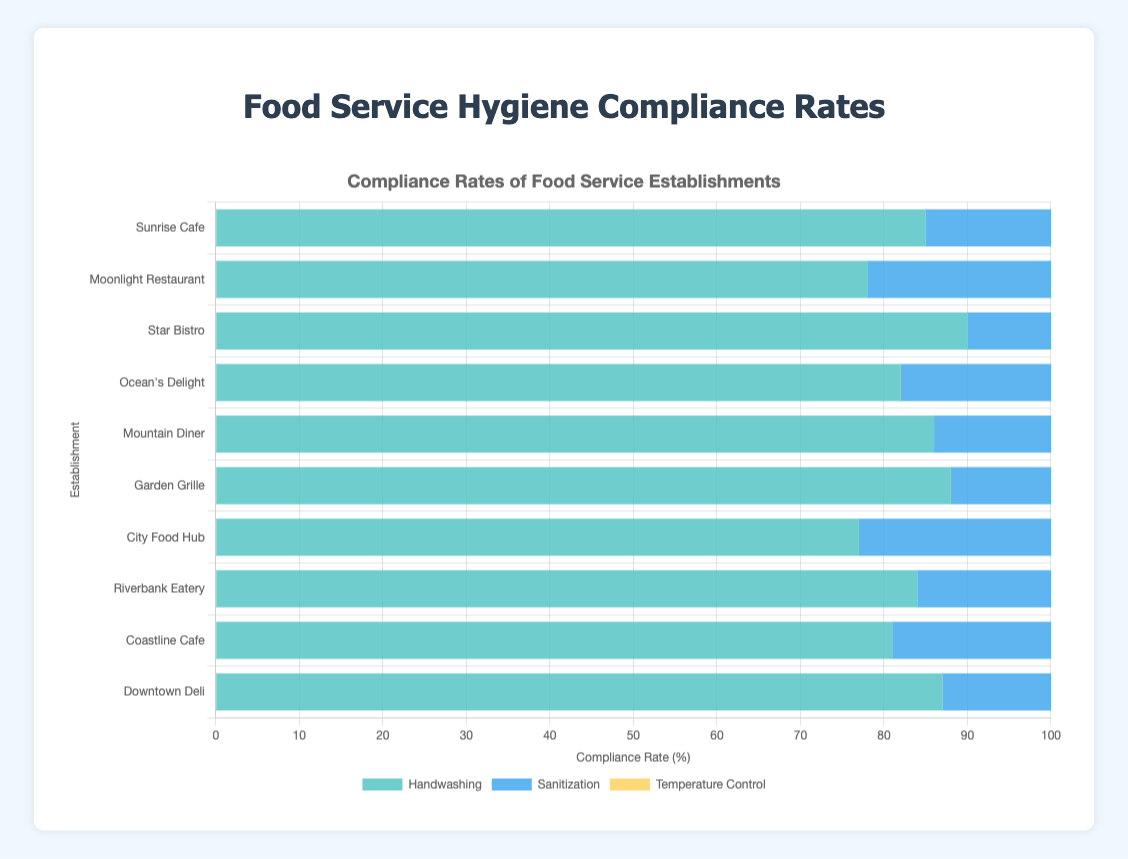Which establishment has the highest handwashing compliance rate? The highest handwashing compliance rate is indicated by the highest bar segment in the "Handwashing" color. Star Bistro has the highest handwashing compliance rate of 90%.
Answer: Star Bistro Which two establishments have equal sanitization compliance rates? Compare the lengths of the "Sanitization" colored bars to check for two equal ones. Both Sunrise Cafe and Downtown Deli have sanitization compliance rates of 90%.
Answer: Sunrise Cafe and Downtown Deli How much more is the temperature control compliance rate for Star Bistro compared to Moonlight Restaurant? Subtract Moonlight Restaurant's temperature control rate (75%) from Star Bistro's (92%). The difference is 92% - 75% = 17%.
Answer: 17% What is the average compliance rate for handwashing across all establishments? Sum the handwashing rates and divide by the number of establishments. (85 + 78 + 90 + 82 + 86 + 88 + 77 + 84 + 81 + 87) / 10 = 83.8%.
Answer: 83.8% Which compliance standard has the lowest rate for Riverbank Eatery? For Riverbank Eatery, compare the bars of different standards to find the shortest one. The shortest bar represents the compliance rate for temperature control at 81%.
Answer: Temperature Control Which establishment shows the greatest variance in compliance rates among the three standards? Calculate the variance by finding the difference between the highest and lowest compliance rates for each establishment, and identify the establishment with the highest difference. Star Bistro has variance: 92% - 88% = 4%, Garden Grille: 89% - 85% = 4%, and so on. Ocean's Delight has the highest variance: 87% - 80% = 7%.
Answer: Ocean's Delight What is the combined average rate for sanitization and temperature control at Garden Grille? Calculate the average of the two rates for Garden Grille. (89 + 85) / 2 = 87%.
Answer: 87% Which compliance standard displays the most consistent rate across all establishments? Visually inspect the grouped bars of each compliance standard and determine which has the least fluctuation in bar length. Handwashing rates appear the most consistent, with values mostly between 77% - 90%.
Answer: Handwashing By how much does the handwashing compliance rate at City Food Hub fall short of the rate at Downtown Deli? Subtract City Food Hub's handwashing rate (77%) from Downtown Deli's (87%). The difference is 87% - 77% = 10%.
Answer: 10% What is the median sanitization compliance rate across all establishments? Order the sanitization compliance rates and identify the middle value. Ordered rates: 82, 83, 84, 85, 86, 87, 88, 89, 90, 90. The median is (86 + 87) / 2 = 86.5%.
Answer: 86.5% 